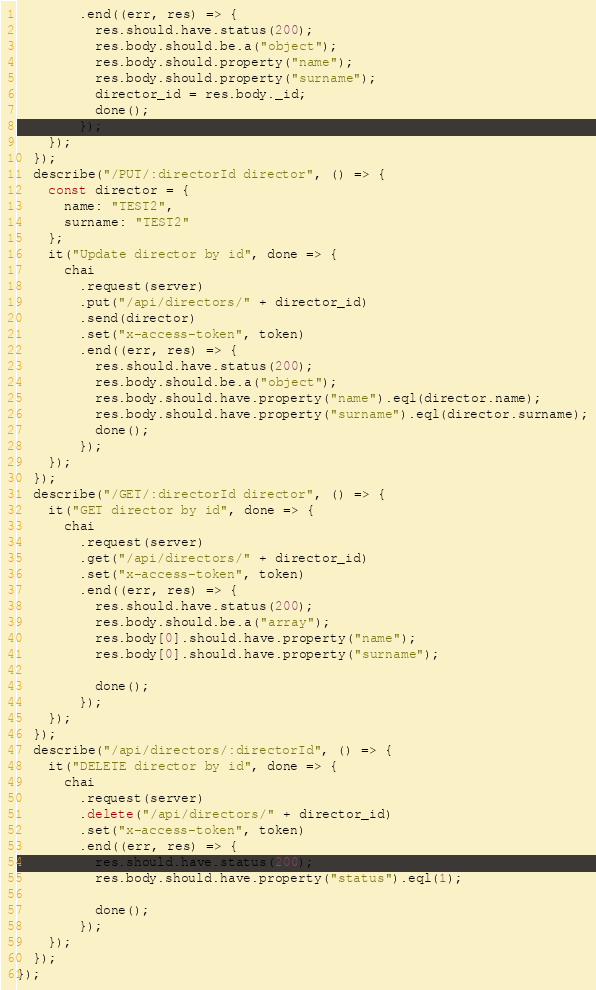<code> <loc_0><loc_0><loc_500><loc_500><_JavaScript_>        .end((err, res) => {
          res.should.have.status(200);
          res.body.should.be.a("object");
          res.body.should.property("name");
          res.body.should.property("surname");
          director_id = res.body._id;
          done();
        });
    });
  });
  describe("/PUT/:directorId director", () => {
    const director = {
      name: "TEST2",
      surname: "TEST2"
    };
    it("Update director by id", done => {
      chai
        .request(server)
        .put("/api/directors/" + director_id)
        .send(director)
        .set("x-access-token", token)
        .end((err, res) => {
          res.should.have.status(200);
          res.body.should.be.a("object");
          res.body.should.have.property("name").eql(director.name);
          res.body.should.have.property("surname").eql(director.surname);
          done();
        });
    });
  });
  describe("/GET/:directorId director", () => {
    it("GET director by id", done => {
      chai
        .request(server)
        .get("/api/directors/" + director_id)
        .set("x-access-token", token)
        .end((err, res) => {
          res.should.have.status(200);
          res.body.should.be.a("array");
          res.body[0].should.have.property("name");
          res.body[0].should.have.property("surname");

          done();
        });
    });
  });
  describe("/api/directors/:directorId", () => {
    it("DELETE director by id", done => {
      chai
        .request(server)
        .delete("/api/directors/" + director_id)
        .set("x-access-token", token)
        .end((err, res) => {
          res.should.have.status(200);
          res.body.should.have.property("status").eql(1);

          done();
        });
    });
  });
});
</code> 